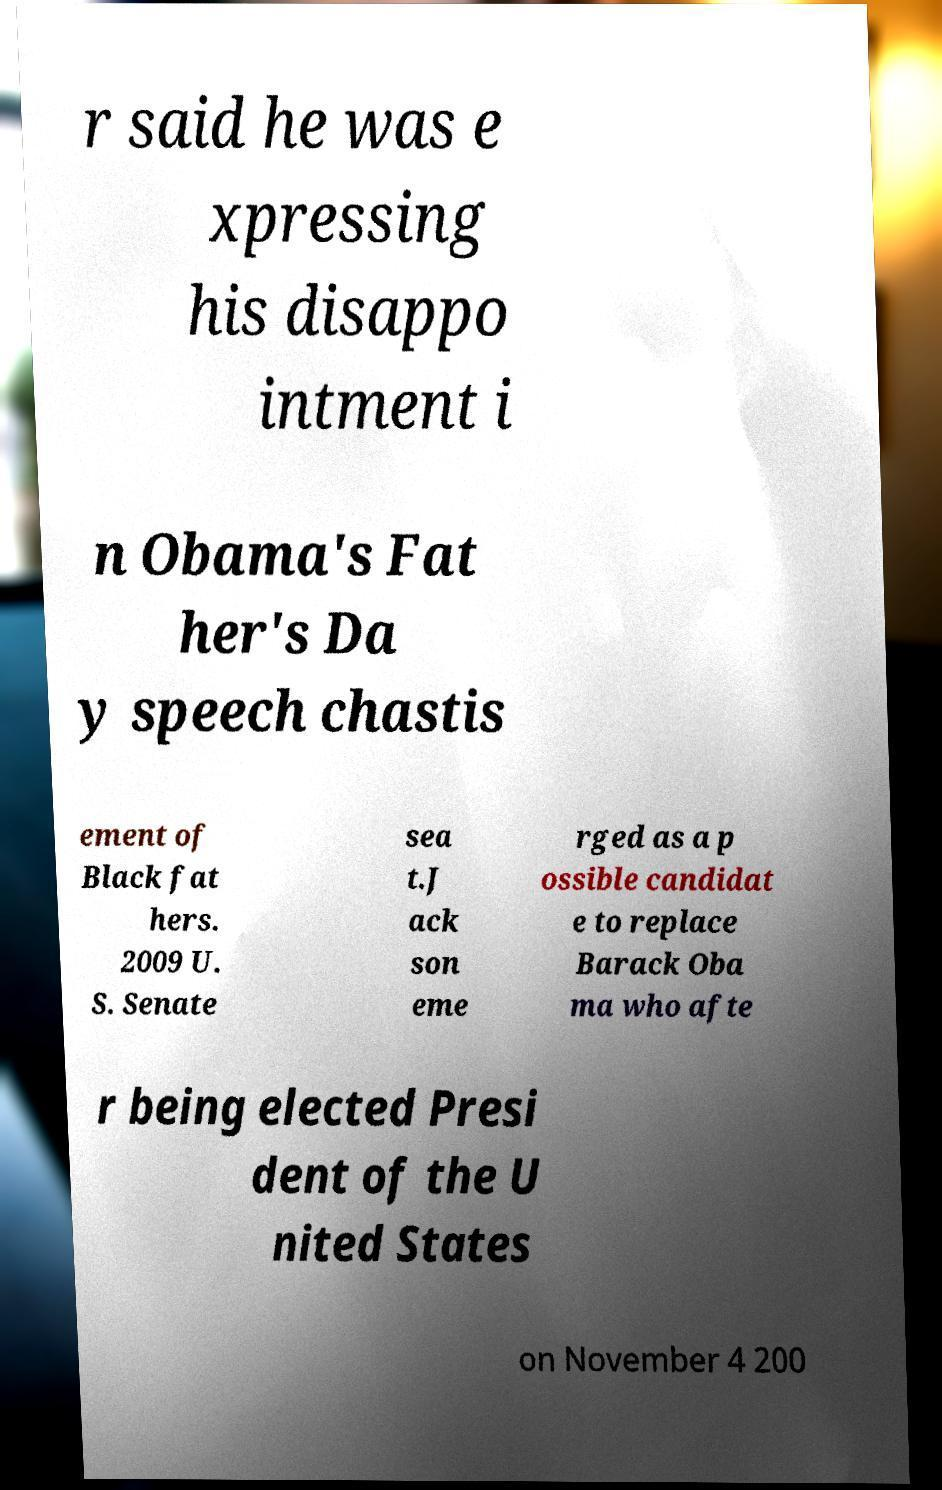Can you read and provide the text displayed in the image?This photo seems to have some interesting text. Can you extract and type it out for me? r said he was e xpressing his disappo intment i n Obama's Fat her's Da y speech chastis ement of Black fat hers. 2009 U. S. Senate sea t.J ack son eme rged as a p ossible candidat e to replace Barack Oba ma who afte r being elected Presi dent of the U nited States on November 4 200 